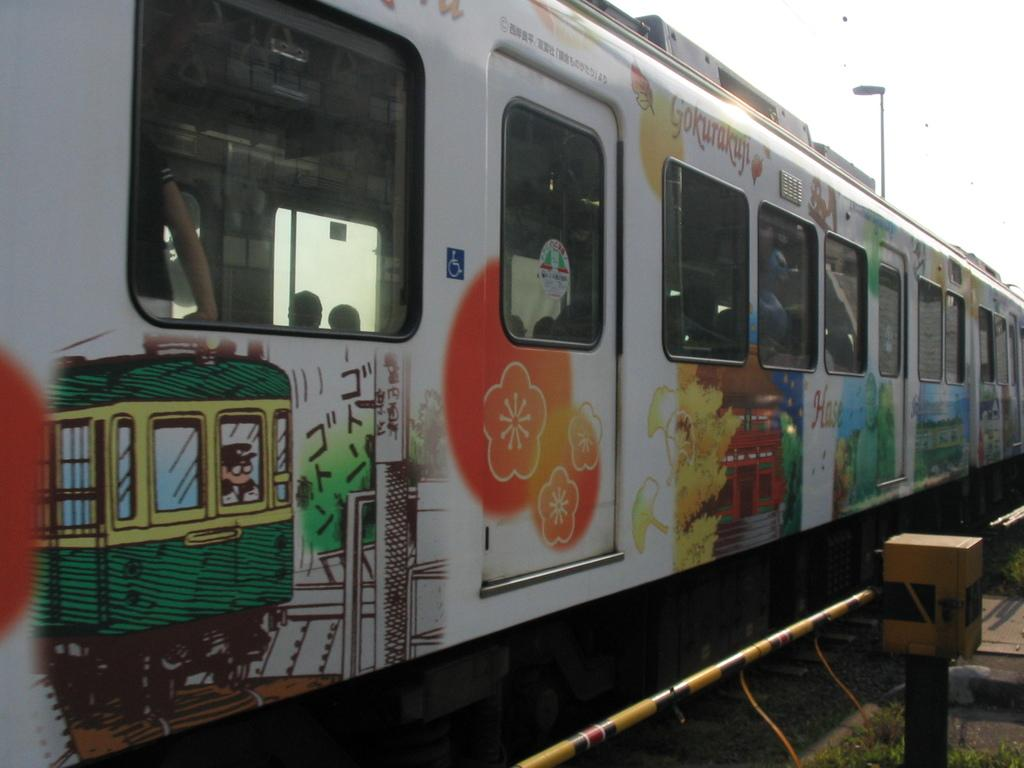What is the main subject of the image? There is a train in the center of the image. Can you describe the train's passengers? There are people inside the train. What can be seen in the background of the image? There are poles, lights, and a rod visible in the background. What type of zipper can be seen on the train in the image? There is no zipper present on the train in the image. Can you describe the rock formation near the train in the image? There is no rock formation visible in the image; it features a train with people inside and various elements in the background. 